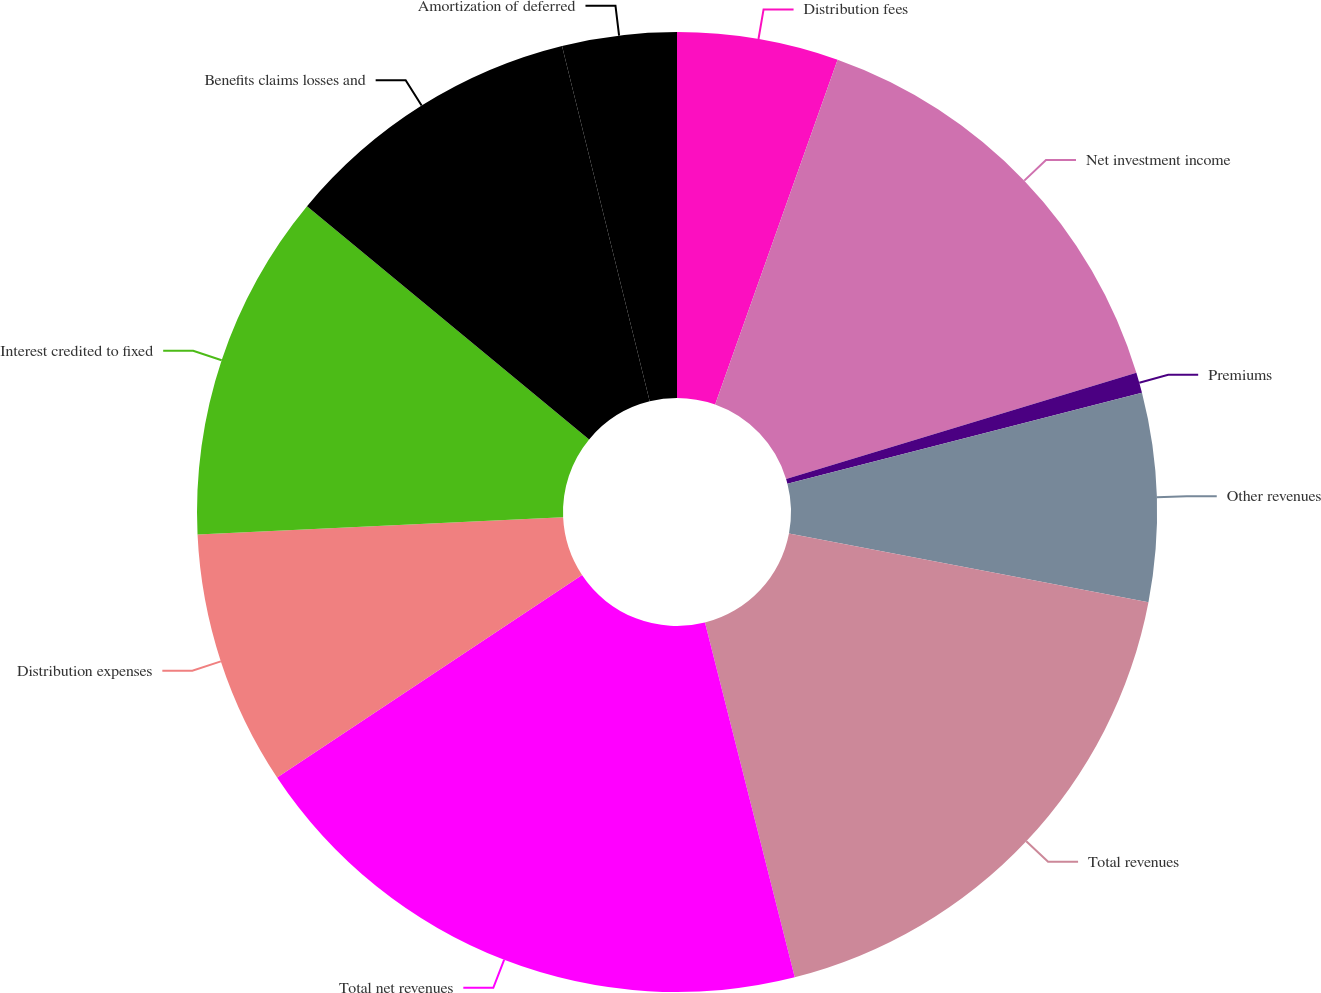Convert chart. <chart><loc_0><loc_0><loc_500><loc_500><pie_chart><fcel>Distribution fees<fcel>Net investment income<fcel>Premiums<fcel>Other revenues<fcel>Total revenues<fcel>Total net revenues<fcel>Distribution expenses<fcel>Interest credited to fixed<fcel>Benefits claims losses and<fcel>Amortization of deferred<nl><fcel>5.43%<fcel>14.89%<fcel>0.69%<fcel>7.0%<fcel>18.05%<fcel>19.62%<fcel>8.58%<fcel>11.74%<fcel>10.16%<fcel>3.85%<nl></chart> 